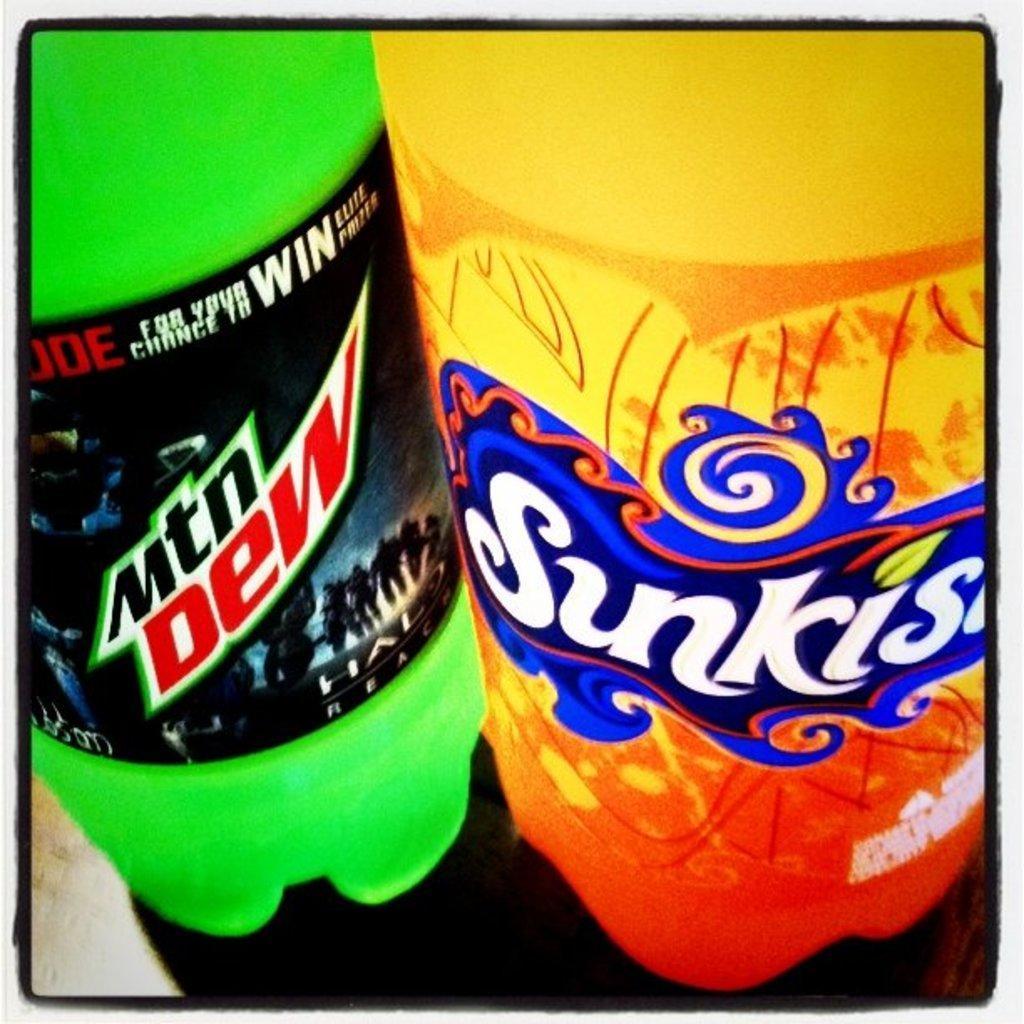Describe this image in one or two sentences. As we can see in the image there are two bottles. 